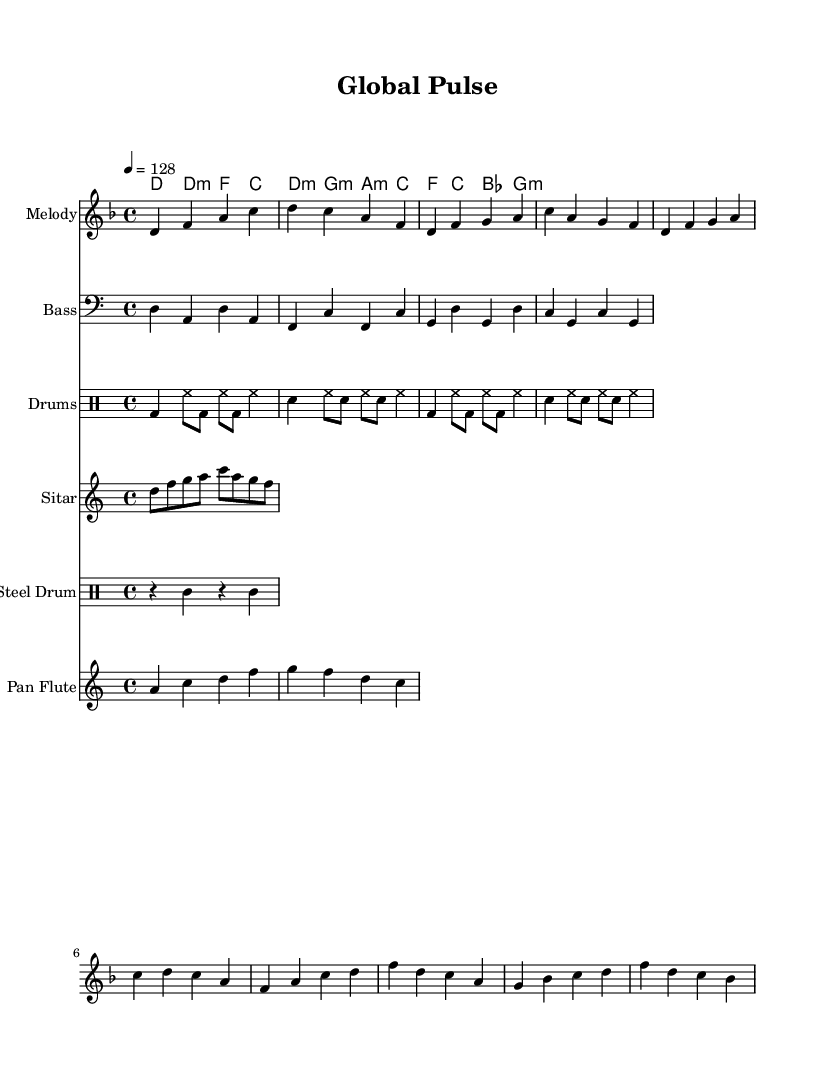What is the key signature of this music? The key signature is D minor, which has one flat (B flat) and corresponds to the notes present in the piece.
Answer: D minor What is the time signature of this piece? The time signature shown in the music is 4/4, indicating four beats per measure, which is typical for dance music.
Answer: 4/4 What is the tempo marking for this composition? The tempo marking at the beginning indicates a tempo of 128 beats per minute, which is characteristic of many electronic dance tracks.
Answer: 128 How many measures are in the chorus section? By counting the measures in the chorus section, which is identified by the specific notes and rhythm, we find there are 4 measures.
Answer: 4 Which instrument primarily carries the melody? The instrument designated to carry the melody in this sheet music is the "Melody," indicating a lead part that stands out.
Answer: Melody What rhythmic pattern is used for the percussion? The percussion part features a consistent pattern using bass drum and snare with alternating hi-hats, characteristic of dance music.
Answer: Alternating bass and snare Which instruments are used to add texture to the dance music? The additional instruments like sitar, steel drum, and pan flute contribute to the textural richness of the piece, reflecting the blending of international sounds.
Answer: Sitar, steel drum, pan flute 